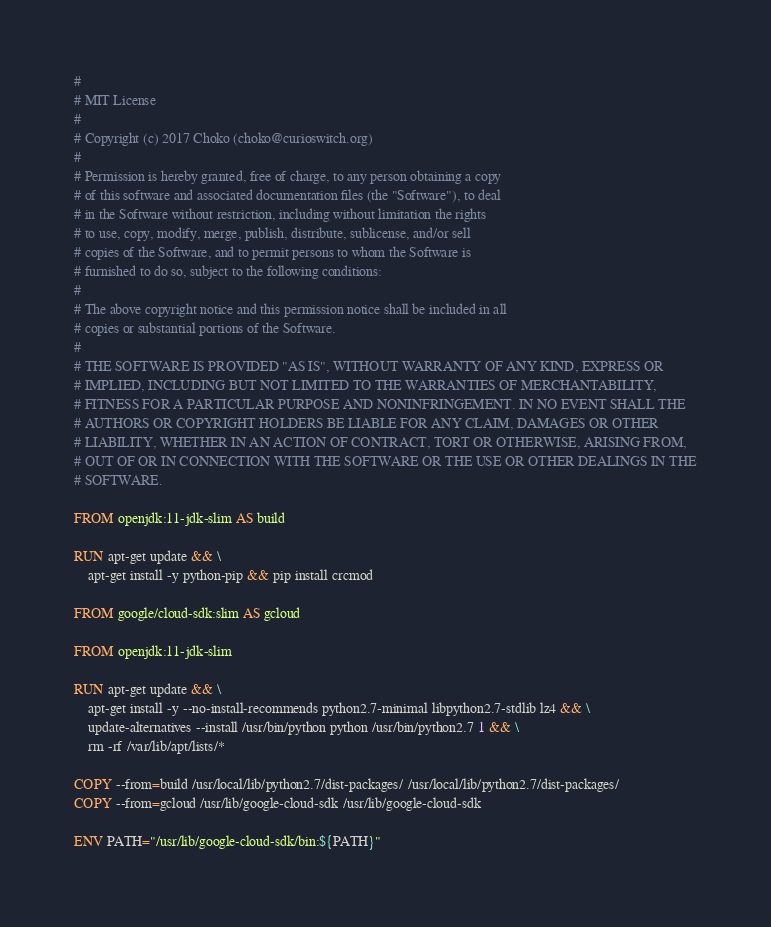Convert code to text. <code><loc_0><loc_0><loc_500><loc_500><_Dockerfile_>#
# MIT License
#
# Copyright (c) 2017 Choko (choko@curioswitch.org)
#
# Permission is hereby granted, free of charge, to any person obtaining a copy
# of this software and associated documentation files (the "Software"), to deal
# in the Software without restriction, including without limitation the rights
# to use, copy, modify, merge, publish, distribute, sublicense, and/or sell
# copies of the Software, and to permit persons to whom the Software is
# furnished to do so, subject to the following conditions:
#
# The above copyright notice and this permission notice shall be included in all
# copies or substantial portions of the Software.
#
# THE SOFTWARE IS PROVIDED "AS IS", WITHOUT WARRANTY OF ANY KIND, EXPRESS OR
# IMPLIED, INCLUDING BUT NOT LIMITED TO THE WARRANTIES OF MERCHANTABILITY,
# FITNESS FOR A PARTICULAR PURPOSE AND NONINFRINGEMENT. IN NO EVENT SHALL THE
# AUTHORS OR COPYRIGHT HOLDERS BE LIABLE FOR ANY CLAIM, DAMAGES OR OTHER
# LIABILITY, WHETHER IN AN ACTION OF CONTRACT, TORT OR OTHERWISE, ARISING FROM,
# OUT OF OR IN CONNECTION WITH THE SOFTWARE OR THE USE OR OTHER DEALINGS IN THE
# SOFTWARE.

FROM openjdk:11-jdk-slim AS build

RUN apt-get update && \
    apt-get install -y python-pip && pip install crcmod

FROM google/cloud-sdk:slim AS gcloud

FROM openjdk:11-jdk-slim

RUN apt-get update && \
    apt-get install -y --no-install-recommends python2.7-minimal libpython2.7-stdlib lz4 && \
    update-alternatives --install /usr/bin/python python /usr/bin/python2.7 1 && \
    rm -rf /var/lib/apt/lists/*

COPY --from=build /usr/local/lib/python2.7/dist-packages/ /usr/local/lib/python2.7/dist-packages/
COPY --from=gcloud /usr/lib/google-cloud-sdk /usr/lib/google-cloud-sdk

ENV PATH="/usr/lib/google-cloud-sdk/bin:${PATH}"
</code> 